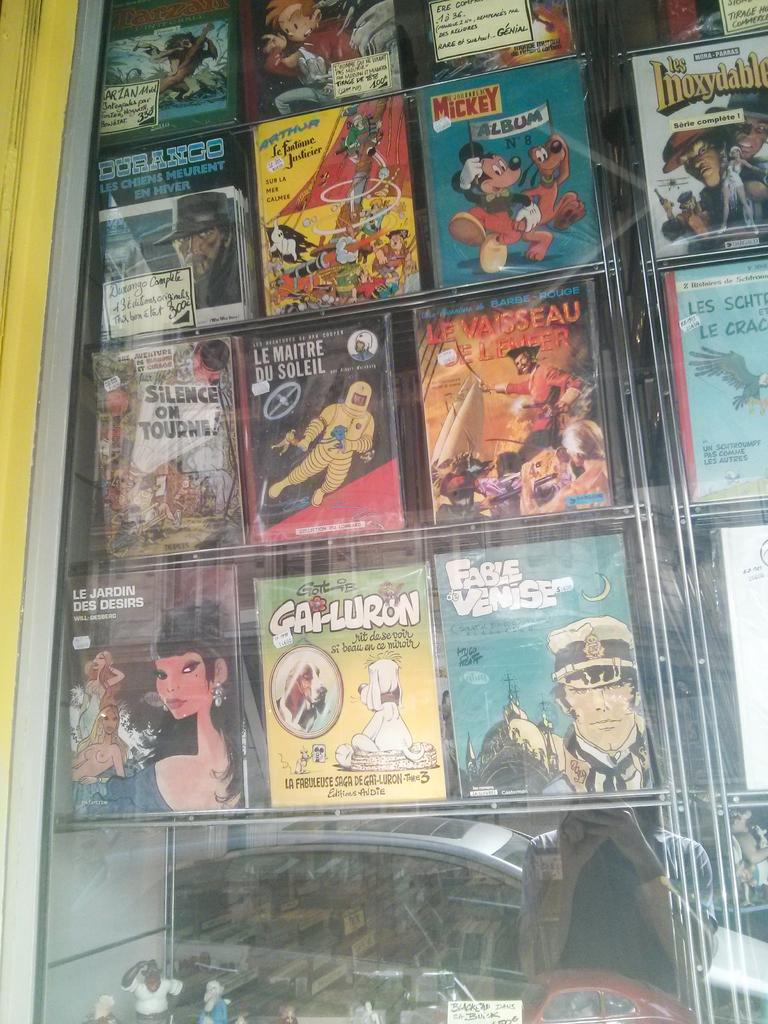What can be seen in the racks in the image? There are books arranged in the racks in the image. What object in the image allows for reflection? There is a mirror in the image. Who or what can be seen in the mirror? A woman is standing and is reflected in the mirror, and a motor vehicle on the road is also reflected in the mirror. What type of territory is visible in the image? There is no territory visible in the image; it primarily features a mirror, a woman, and a motor vehicle reflected in the mirror. How many bulbs are present in the image? There is no mention of bulbs in the provided facts, so we cannot determine their presence or quantity in the image. 